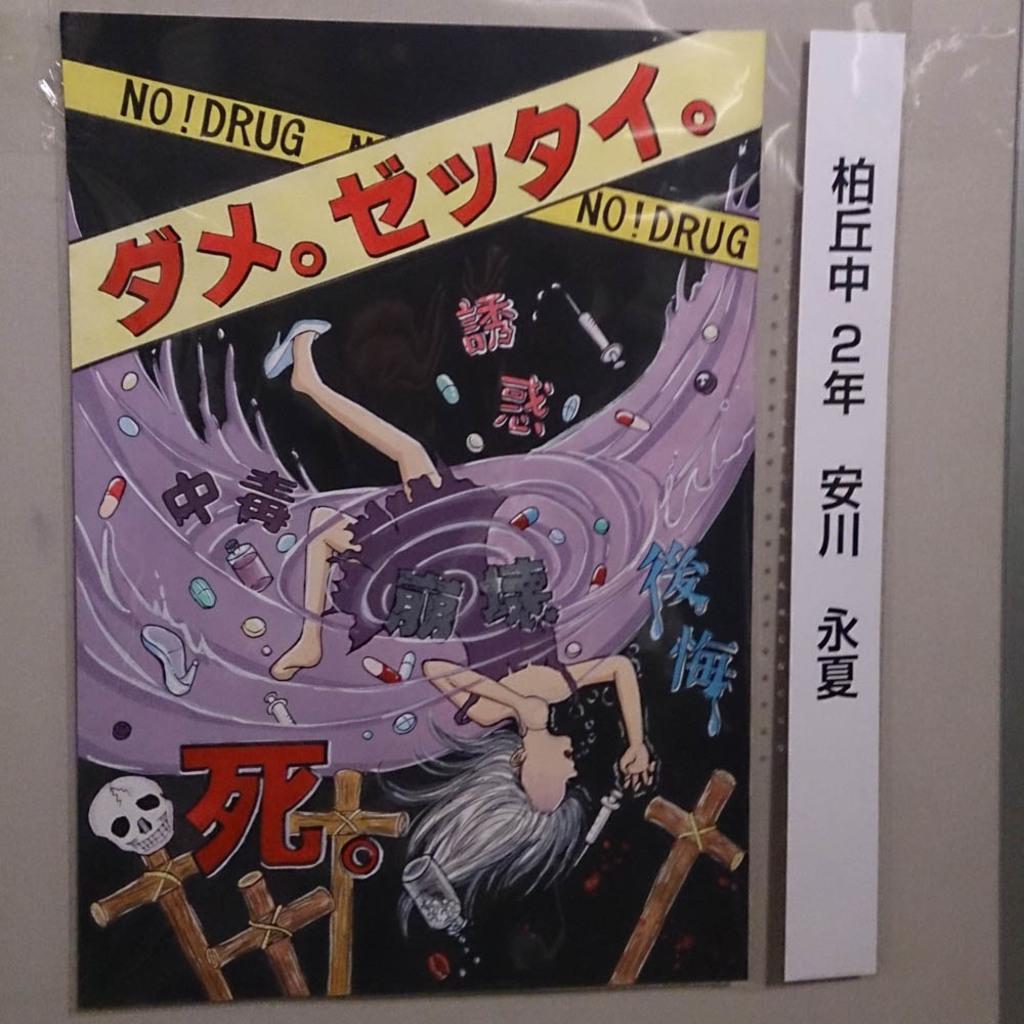Can you describe this image briefly? In this image we can see a poster attached to the plain wall and on the poster we can see the images of skull, cross, bottle and also the depiction of a woman. We can also see the text in English and also in different language. 